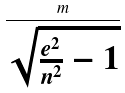<formula> <loc_0><loc_0><loc_500><loc_500>\frac { m } { \sqrt { \frac { e ^ { 2 } } { n ^ { 2 } } - 1 } }</formula> 